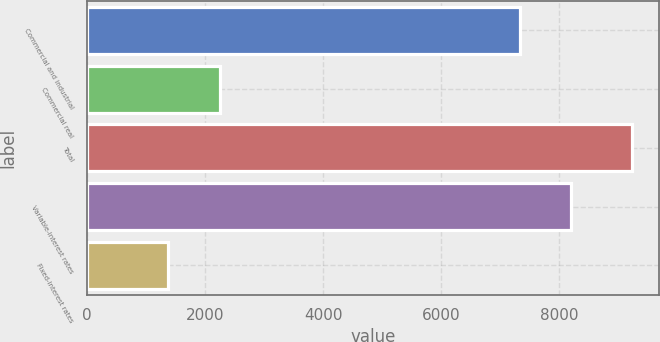Convert chart. <chart><loc_0><loc_0><loc_500><loc_500><bar_chart><fcel>Commercial and industrial<fcel>Commercial real<fcel>Total<fcel>Variable-interest rates<fcel>Fixed-interest rates<nl><fcel>7334<fcel>2248.2<fcel>9241<fcel>8208.1<fcel>1374.1<nl></chart> 